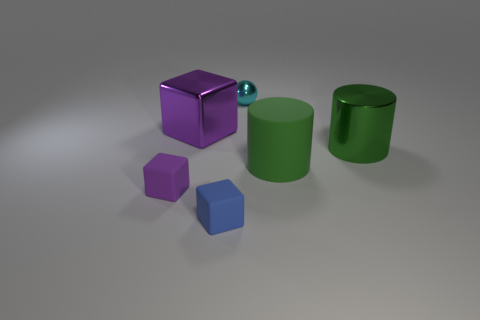There is a small cube on the left side of the blue cube; what color is it?
Your answer should be very brief. Purple. How many cubes are on the left side of the object behind the purple block behind the small purple block?
Your answer should be very brief. 3. How many objects are to the left of the purple shiny object that is to the left of the tiny blue block?
Your answer should be very brief. 1. How many rubber cubes are in front of the big rubber cylinder?
Ensure brevity in your answer.  2. How many other things are there of the same size as the blue rubber thing?
Make the answer very short. 2. What size is the other shiny object that is the same shape as the small blue object?
Provide a short and direct response. Large. What is the shape of the tiny object that is behind the small purple cube?
Provide a short and direct response. Sphere. There is a small cube that is right of the cube on the left side of the purple metal object; what color is it?
Your answer should be very brief. Blue. What number of objects are tiny things that are to the left of the cyan metallic sphere or tiny gray matte cylinders?
Keep it short and to the point. 2. There is a rubber cylinder; does it have the same size as the matte cube that is right of the small purple rubber block?
Your response must be concise. No. 